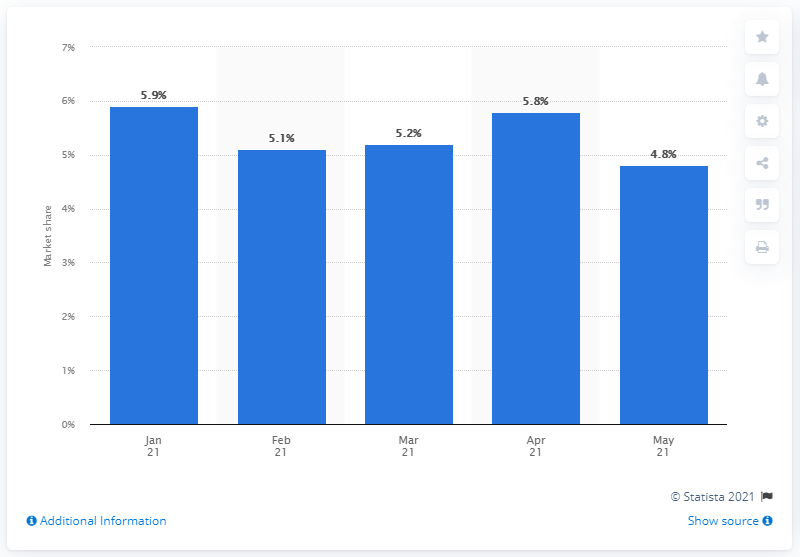List a handful of essential elements in this visual. In May 2021, Mercedes held a market share of 4.8% in the European Union. 